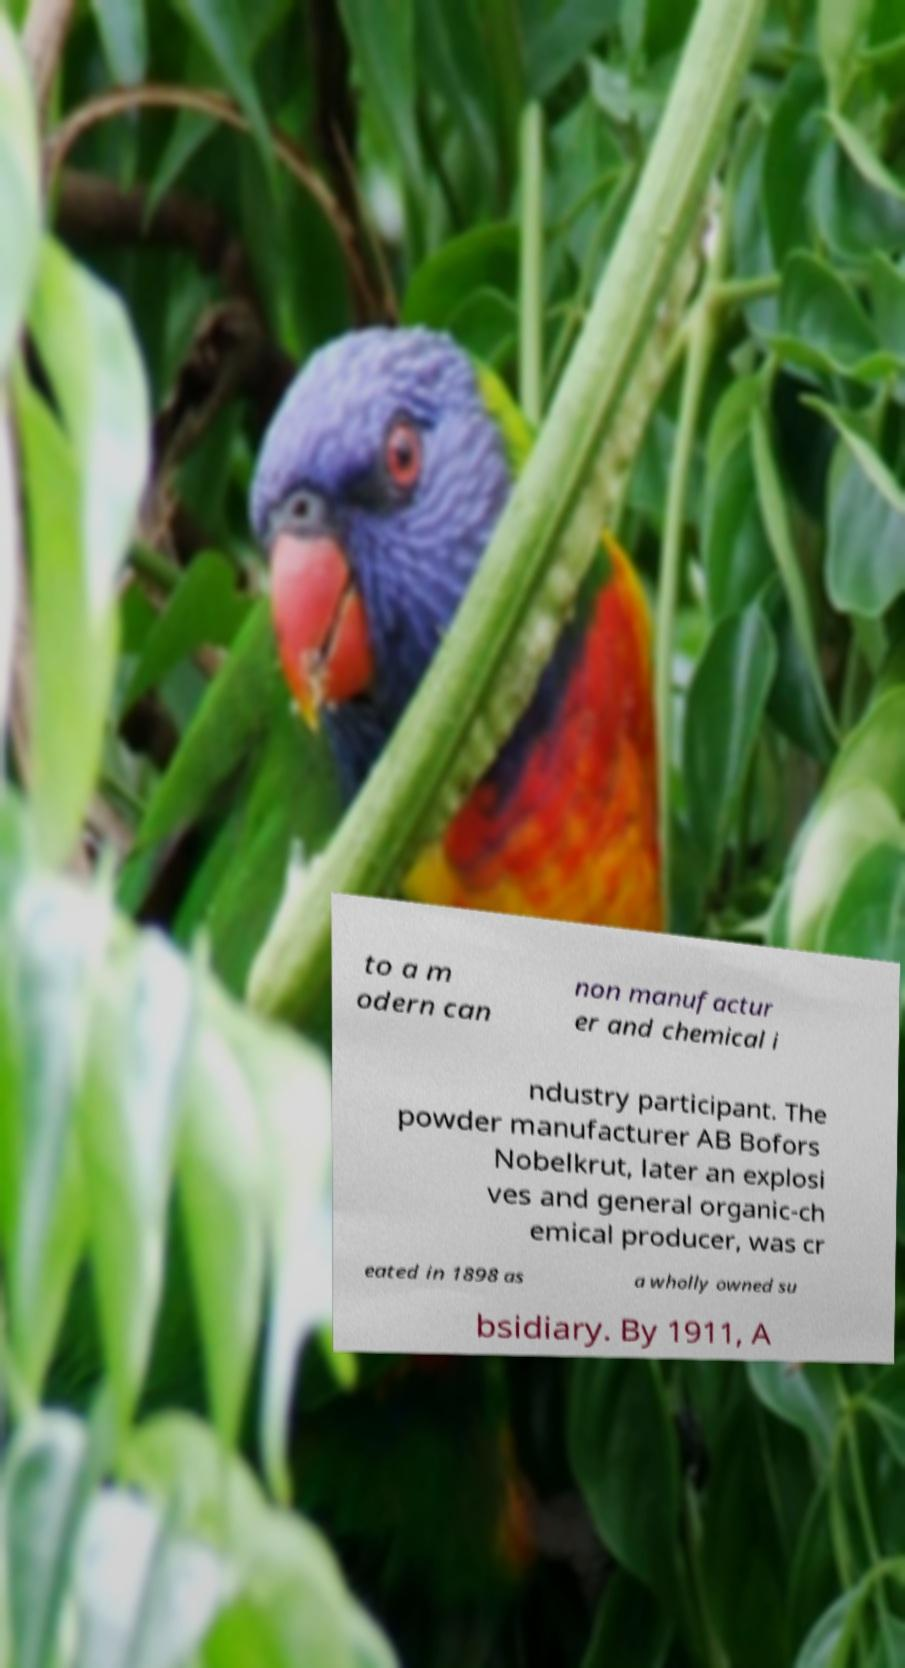For documentation purposes, I need the text within this image transcribed. Could you provide that? to a m odern can non manufactur er and chemical i ndustry participant. The powder manufacturer AB Bofors Nobelkrut, later an explosi ves and general organic-ch emical producer, was cr eated in 1898 as a wholly owned su bsidiary. By 1911, A 